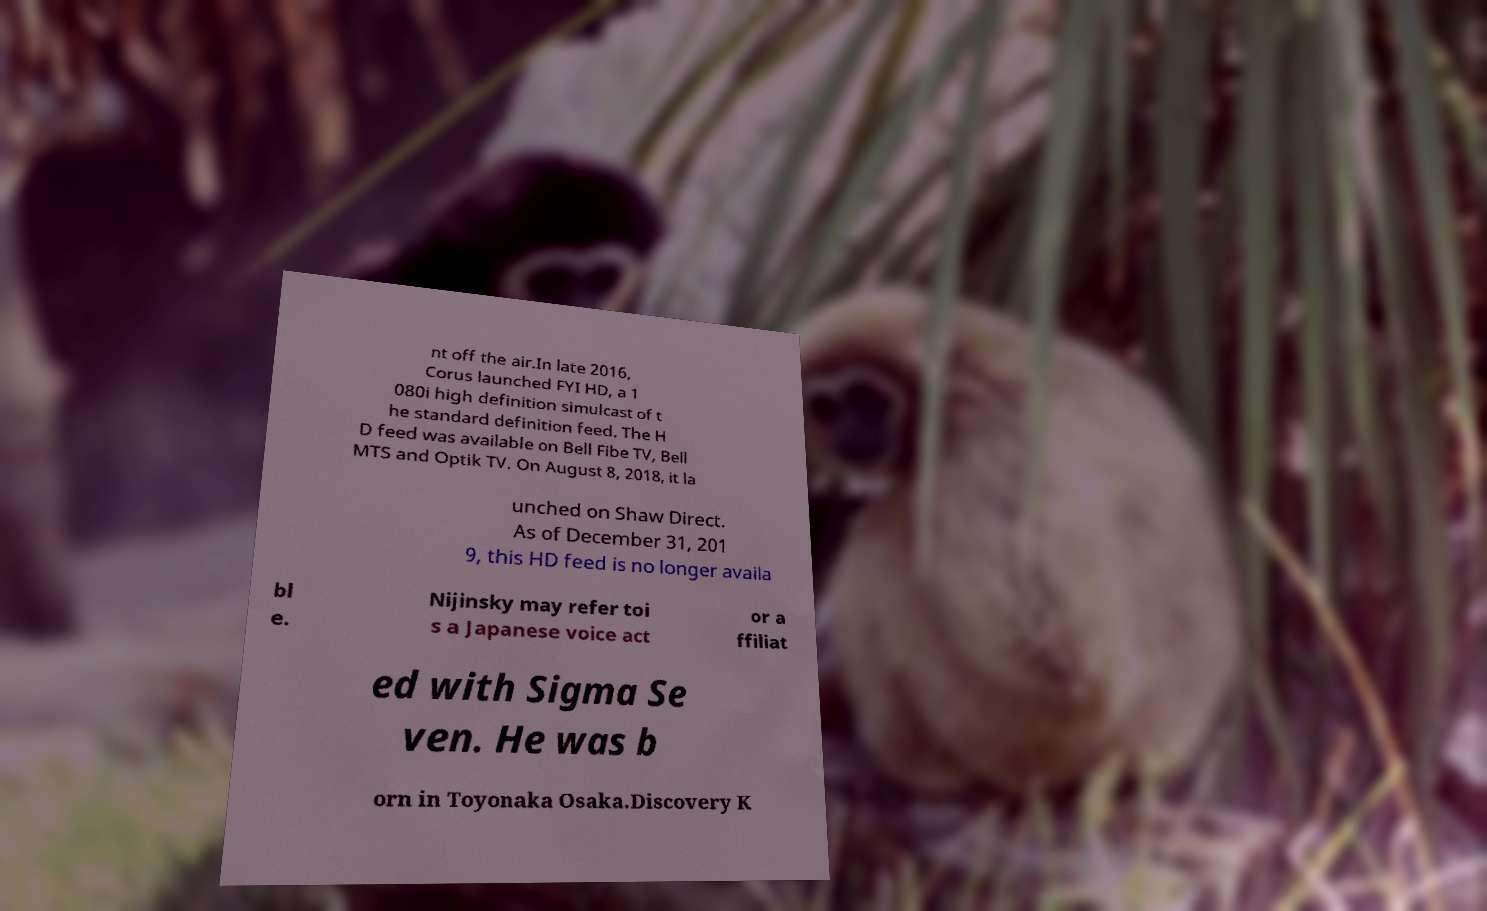Please read and relay the text visible in this image. What does it say? nt off the air.In late 2016, Corus launched FYI HD, a 1 080i high definition simulcast of t he standard definition feed. The H D feed was available on Bell Fibe TV, Bell MTS and Optik TV. On August 8, 2018, it la unched on Shaw Direct. As of December 31, 201 9, this HD feed is no longer availa bl e. Nijinsky may refer toi s a Japanese voice act or a ffiliat ed with Sigma Se ven. He was b orn in Toyonaka Osaka.Discovery K 